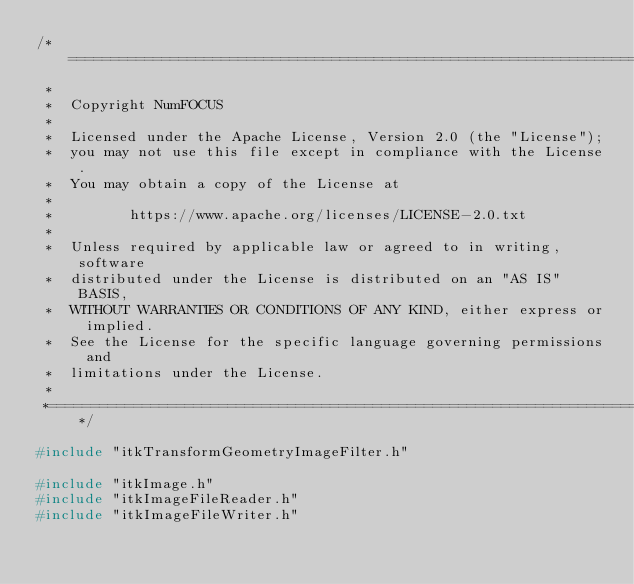<code> <loc_0><loc_0><loc_500><loc_500><_C++_>/*=========================================================================
 *
 *  Copyright NumFOCUS
 *
 *  Licensed under the Apache License, Version 2.0 (the "License");
 *  you may not use this file except in compliance with the License.
 *  You may obtain a copy of the License at
 *
 *         https://www.apache.org/licenses/LICENSE-2.0.txt
 *
 *  Unless required by applicable law or agreed to in writing, software
 *  distributed under the License is distributed on an "AS IS" BASIS,
 *  WITHOUT WARRANTIES OR CONDITIONS OF ANY KIND, either express or implied.
 *  See the License for the specific language governing permissions and
 *  limitations under the License.
 *
 *=========================================================================*/

#include "itkTransformGeometryImageFilter.h"

#include "itkImage.h"
#include "itkImageFileReader.h"
#include "itkImageFileWriter.h"</code> 